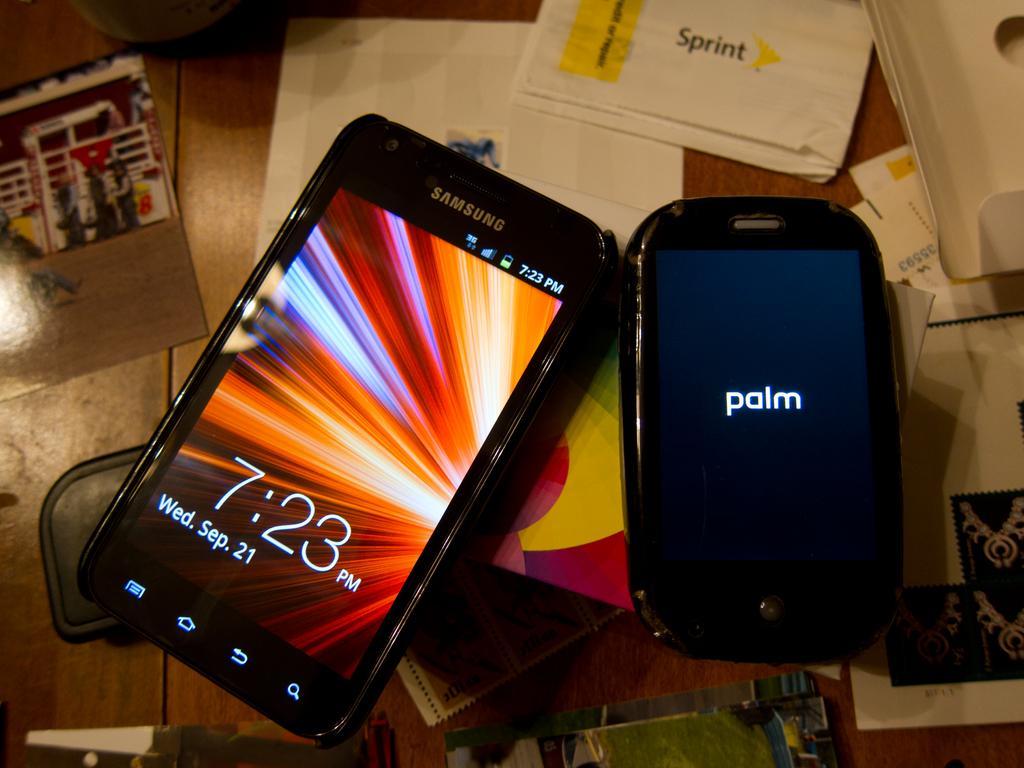Describe this image in one or two sentences. In this image I can see the mobiles. To the side of mobiles I can see the photos and many papers. These are on the brown color surface. 